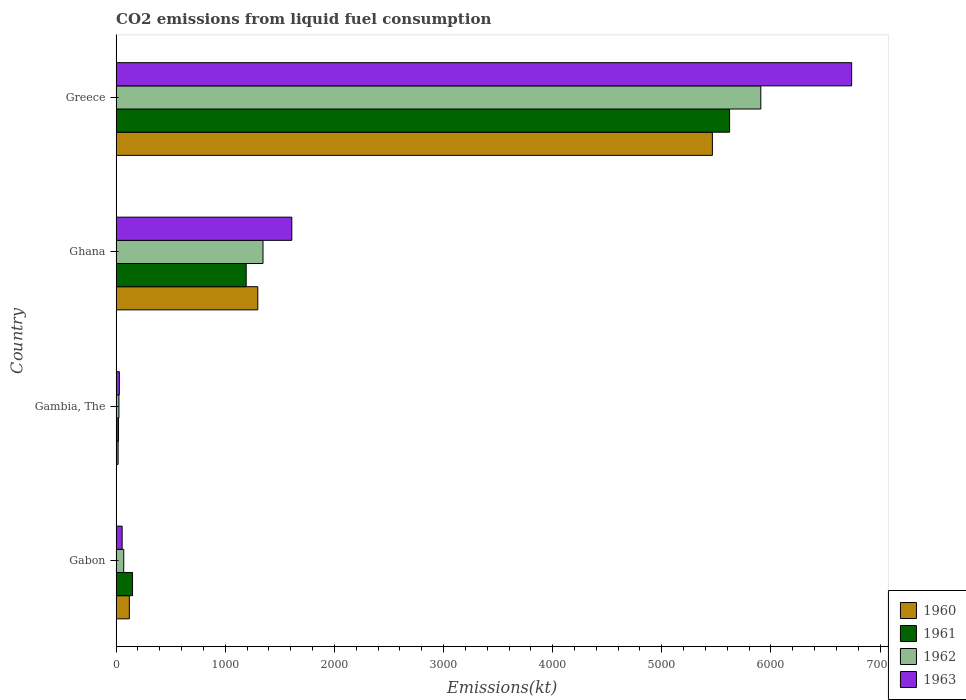How many different coloured bars are there?
Your answer should be compact. 4. How many groups of bars are there?
Keep it short and to the point. 4. Are the number of bars per tick equal to the number of legend labels?
Offer a very short reply. Yes. Are the number of bars on each tick of the Y-axis equal?
Make the answer very short. Yes. How many bars are there on the 3rd tick from the top?
Give a very brief answer. 4. What is the label of the 2nd group of bars from the top?
Provide a succinct answer. Ghana. What is the amount of CO2 emitted in 1960 in Gabon?
Your answer should be very brief. 121.01. Across all countries, what is the maximum amount of CO2 emitted in 1960?
Provide a short and direct response. 5463.83. Across all countries, what is the minimum amount of CO2 emitted in 1960?
Offer a terse response. 18.34. In which country was the amount of CO2 emitted in 1960 maximum?
Offer a terse response. Greece. In which country was the amount of CO2 emitted in 1960 minimum?
Give a very brief answer. Gambia, The. What is the total amount of CO2 emitted in 1962 in the graph?
Provide a short and direct response. 7348.67. What is the difference between the amount of CO2 emitted in 1963 in Gabon and that in Greece?
Make the answer very short. -6684.94. What is the difference between the amount of CO2 emitted in 1960 in Ghana and the amount of CO2 emitted in 1962 in Gabon?
Offer a terse response. 1228.44. What is the average amount of CO2 emitted in 1960 per country?
Keep it short and to the point. 1725.32. What is the difference between the amount of CO2 emitted in 1962 and amount of CO2 emitted in 1963 in Gabon?
Provide a short and direct response. 14.67. What is the ratio of the amount of CO2 emitted in 1961 in Gabon to that in Ghana?
Keep it short and to the point. 0.13. Is the amount of CO2 emitted in 1963 in Gabon less than that in Ghana?
Provide a short and direct response. Yes. Is the difference between the amount of CO2 emitted in 1962 in Gambia, The and Greece greater than the difference between the amount of CO2 emitted in 1963 in Gambia, The and Greece?
Ensure brevity in your answer.  Yes. What is the difference between the highest and the second highest amount of CO2 emitted in 1961?
Make the answer very short. 4429.74. What is the difference between the highest and the lowest amount of CO2 emitted in 1961?
Keep it short and to the point. 5599.51. Is it the case that in every country, the sum of the amount of CO2 emitted in 1960 and amount of CO2 emitted in 1963 is greater than the sum of amount of CO2 emitted in 1961 and amount of CO2 emitted in 1962?
Ensure brevity in your answer.  No. What does the 3rd bar from the bottom in Greece represents?
Provide a short and direct response. 1962. Is it the case that in every country, the sum of the amount of CO2 emitted in 1962 and amount of CO2 emitted in 1961 is greater than the amount of CO2 emitted in 1963?
Your response must be concise. Yes. Are all the bars in the graph horizontal?
Give a very brief answer. Yes. Where does the legend appear in the graph?
Keep it short and to the point. Bottom right. How many legend labels are there?
Provide a succinct answer. 4. What is the title of the graph?
Make the answer very short. CO2 emissions from liquid fuel consumption. What is the label or title of the X-axis?
Your response must be concise. Emissions(kt). What is the label or title of the Y-axis?
Provide a succinct answer. Country. What is the Emissions(kt) of 1960 in Gabon?
Offer a terse response. 121.01. What is the Emissions(kt) in 1961 in Gabon?
Make the answer very short. 150.35. What is the Emissions(kt) of 1962 in Gabon?
Give a very brief answer. 69.67. What is the Emissions(kt) of 1963 in Gabon?
Provide a succinct answer. 55.01. What is the Emissions(kt) in 1960 in Gambia, The?
Offer a terse response. 18.34. What is the Emissions(kt) of 1961 in Gambia, The?
Offer a very short reply. 22. What is the Emissions(kt) of 1962 in Gambia, The?
Offer a terse response. 25.67. What is the Emissions(kt) in 1963 in Gambia, The?
Your response must be concise. 29.34. What is the Emissions(kt) in 1960 in Ghana?
Provide a succinct answer. 1298.12. What is the Emissions(kt) in 1961 in Ghana?
Your answer should be compact. 1191.78. What is the Emissions(kt) of 1962 in Ghana?
Ensure brevity in your answer.  1345.79. What is the Emissions(kt) of 1963 in Ghana?
Your answer should be very brief. 1609.81. What is the Emissions(kt) of 1960 in Greece?
Your answer should be very brief. 5463.83. What is the Emissions(kt) of 1961 in Greece?
Your answer should be compact. 5621.51. What is the Emissions(kt) of 1962 in Greece?
Offer a very short reply. 5907.54. What is the Emissions(kt) of 1963 in Greece?
Your answer should be very brief. 6739.95. Across all countries, what is the maximum Emissions(kt) of 1960?
Offer a very short reply. 5463.83. Across all countries, what is the maximum Emissions(kt) in 1961?
Your answer should be compact. 5621.51. Across all countries, what is the maximum Emissions(kt) of 1962?
Offer a very short reply. 5907.54. Across all countries, what is the maximum Emissions(kt) of 1963?
Give a very brief answer. 6739.95. Across all countries, what is the minimum Emissions(kt) in 1960?
Make the answer very short. 18.34. Across all countries, what is the minimum Emissions(kt) of 1961?
Your answer should be very brief. 22. Across all countries, what is the minimum Emissions(kt) of 1962?
Your answer should be compact. 25.67. Across all countries, what is the minimum Emissions(kt) in 1963?
Provide a succinct answer. 29.34. What is the total Emissions(kt) in 1960 in the graph?
Your response must be concise. 6901.29. What is the total Emissions(kt) in 1961 in the graph?
Your response must be concise. 6985.64. What is the total Emissions(kt) of 1962 in the graph?
Your answer should be compact. 7348.67. What is the total Emissions(kt) in 1963 in the graph?
Make the answer very short. 8434.1. What is the difference between the Emissions(kt) of 1960 in Gabon and that in Gambia, The?
Ensure brevity in your answer.  102.68. What is the difference between the Emissions(kt) in 1961 in Gabon and that in Gambia, The?
Your response must be concise. 128.34. What is the difference between the Emissions(kt) of 1962 in Gabon and that in Gambia, The?
Give a very brief answer. 44. What is the difference between the Emissions(kt) of 1963 in Gabon and that in Gambia, The?
Your answer should be compact. 25.67. What is the difference between the Emissions(kt) of 1960 in Gabon and that in Ghana?
Give a very brief answer. -1177.11. What is the difference between the Emissions(kt) in 1961 in Gabon and that in Ghana?
Your response must be concise. -1041.43. What is the difference between the Emissions(kt) in 1962 in Gabon and that in Ghana?
Offer a very short reply. -1276.12. What is the difference between the Emissions(kt) in 1963 in Gabon and that in Ghana?
Offer a terse response. -1554.81. What is the difference between the Emissions(kt) in 1960 in Gabon and that in Greece?
Offer a terse response. -5342.82. What is the difference between the Emissions(kt) in 1961 in Gabon and that in Greece?
Provide a short and direct response. -5471.16. What is the difference between the Emissions(kt) in 1962 in Gabon and that in Greece?
Offer a very short reply. -5837.86. What is the difference between the Emissions(kt) of 1963 in Gabon and that in Greece?
Make the answer very short. -6684.94. What is the difference between the Emissions(kt) in 1960 in Gambia, The and that in Ghana?
Give a very brief answer. -1279.78. What is the difference between the Emissions(kt) in 1961 in Gambia, The and that in Ghana?
Provide a short and direct response. -1169.77. What is the difference between the Emissions(kt) in 1962 in Gambia, The and that in Ghana?
Offer a terse response. -1320.12. What is the difference between the Emissions(kt) of 1963 in Gambia, The and that in Ghana?
Offer a very short reply. -1580.48. What is the difference between the Emissions(kt) of 1960 in Gambia, The and that in Greece?
Your answer should be very brief. -5445.49. What is the difference between the Emissions(kt) of 1961 in Gambia, The and that in Greece?
Your answer should be compact. -5599.51. What is the difference between the Emissions(kt) of 1962 in Gambia, The and that in Greece?
Your response must be concise. -5881.87. What is the difference between the Emissions(kt) of 1963 in Gambia, The and that in Greece?
Give a very brief answer. -6710.61. What is the difference between the Emissions(kt) in 1960 in Ghana and that in Greece?
Your response must be concise. -4165.71. What is the difference between the Emissions(kt) in 1961 in Ghana and that in Greece?
Provide a short and direct response. -4429.74. What is the difference between the Emissions(kt) of 1962 in Ghana and that in Greece?
Keep it short and to the point. -4561.75. What is the difference between the Emissions(kt) of 1963 in Ghana and that in Greece?
Your response must be concise. -5130.13. What is the difference between the Emissions(kt) in 1960 in Gabon and the Emissions(kt) in 1961 in Gambia, The?
Give a very brief answer. 99.01. What is the difference between the Emissions(kt) of 1960 in Gabon and the Emissions(kt) of 1962 in Gambia, The?
Your answer should be very brief. 95.34. What is the difference between the Emissions(kt) of 1960 in Gabon and the Emissions(kt) of 1963 in Gambia, The?
Offer a terse response. 91.67. What is the difference between the Emissions(kt) in 1961 in Gabon and the Emissions(kt) in 1962 in Gambia, The?
Your answer should be very brief. 124.68. What is the difference between the Emissions(kt) in 1961 in Gabon and the Emissions(kt) in 1963 in Gambia, The?
Your response must be concise. 121.01. What is the difference between the Emissions(kt) in 1962 in Gabon and the Emissions(kt) in 1963 in Gambia, The?
Make the answer very short. 40.34. What is the difference between the Emissions(kt) of 1960 in Gabon and the Emissions(kt) of 1961 in Ghana?
Provide a short and direct response. -1070.76. What is the difference between the Emissions(kt) in 1960 in Gabon and the Emissions(kt) in 1962 in Ghana?
Give a very brief answer. -1224.78. What is the difference between the Emissions(kt) in 1960 in Gabon and the Emissions(kt) in 1963 in Ghana?
Provide a succinct answer. -1488.8. What is the difference between the Emissions(kt) of 1961 in Gabon and the Emissions(kt) of 1962 in Ghana?
Offer a terse response. -1195.44. What is the difference between the Emissions(kt) in 1961 in Gabon and the Emissions(kt) in 1963 in Ghana?
Offer a terse response. -1459.47. What is the difference between the Emissions(kt) of 1962 in Gabon and the Emissions(kt) of 1963 in Ghana?
Your answer should be very brief. -1540.14. What is the difference between the Emissions(kt) in 1960 in Gabon and the Emissions(kt) in 1961 in Greece?
Give a very brief answer. -5500.5. What is the difference between the Emissions(kt) in 1960 in Gabon and the Emissions(kt) in 1962 in Greece?
Your answer should be very brief. -5786.53. What is the difference between the Emissions(kt) in 1960 in Gabon and the Emissions(kt) in 1963 in Greece?
Provide a succinct answer. -6618.94. What is the difference between the Emissions(kt) of 1961 in Gabon and the Emissions(kt) of 1962 in Greece?
Ensure brevity in your answer.  -5757.19. What is the difference between the Emissions(kt) in 1961 in Gabon and the Emissions(kt) in 1963 in Greece?
Make the answer very short. -6589.6. What is the difference between the Emissions(kt) in 1962 in Gabon and the Emissions(kt) in 1963 in Greece?
Your answer should be compact. -6670.27. What is the difference between the Emissions(kt) in 1960 in Gambia, The and the Emissions(kt) in 1961 in Ghana?
Your answer should be compact. -1173.44. What is the difference between the Emissions(kt) of 1960 in Gambia, The and the Emissions(kt) of 1962 in Ghana?
Keep it short and to the point. -1327.45. What is the difference between the Emissions(kt) in 1960 in Gambia, The and the Emissions(kt) in 1963 in Ghana?
Provide a succinct answer. -1591.48. What is the difference between the Emissions(kt) of 1961 in Gambia, The and the Emissions(kt) of 1962 in Ghana?
Offer a terse response. -1323.79. What is the difference between the Emissions(kt) in 1961 in Gambia, The and the Emissions(kt) in 1963 in Ghana?
Give a very brief answer. -1587.81. What is the difference between the Emissions(kt) in 1962 in Gambia, The and the Emissions(kt) in 1963 in Ghana?
Provide a succinct answer. -1584.14. What is the difference between the Emissions(kt) in 1960 in Gambia, The and the Emissions(kt) in 1961 in Greece?
Give a very brief answer. -5603.18. What is the difference between the Emissions(kt) in 1960 in Gambia, The and the Emissions(kt) in 1962 in Greece?
Your response must be concise. -5889.2. What is the difference between the Emissions(kt) of 1960 in Gambia, The and the Emissions(kt) of 1963 in Greece?
Your response must be concise. -6721.61. What is the difference between the Emissions(kt) in 1961 in Gambia, The and the Emissions(kt) in 1962 in Greece?
Give a very brief answer. -5885.53. What is the difference between the Emissions(kt) in 1961 in Gambia, The and the Emissions(kt) in 1963 in Greece?
Your response must be concise. -6717.94. What is the difference between the Emissions(kt) in 1962 in Gambia, The and the Emissions(kt) in 1963 in Greece?
Your answer should be very brief. -6714.28. What is the difference between the Emissions(kt) of 1960 in Ghana and the Emissions(kt) of 1961 in Greece?
Offer a terse response. -4323.39. What is the difference between the Emissions(kt) of 1960 in Ghana and the Emissions(kt) of 1962 in Greece?
Give a very brief answer. -4609.42. What is the difference between the Emissions(kt) in 1960 in Ghana and the Emissions(kt) in 1963 in Greece?
Offer a terse response. -5441.83. What is the difference between the Emissions(kt) in 1961 in Ghana and the Emissions(kt) in 1962 in Greece?
Give a very brief answer. -4715.76. What is the difference between the Emissions(kt) of 1961 in Ghana and the Emissions(kt) of 1963 in Greece?
Provide a succinct answer. -5548.17. What is the difference between the Emissions(kt) in 1962 in Ghana and the Emissions(kt) in 1963 in Greece?
Offer a very short reply. -5394.16. What is the average Emissions(kt) of 1960 per country?
Ensure brevity in your answer.  1725.32. What is the average Emissions(kt) of 1961 per country?
Keep it short and to the point. 1746.41. What is the average Emissions(kt) of 1962 per country?
Make the answer very short. 1837.17. What is the average Emissions(kt) in 1963 per country?
Provide a succinct answer. 2108.53. What is the difference between the Emissions(kt) in 1960 and Emissions(kt) in 1961 in Gabon?
Your answer should be compact. -29.34. What is the difference between the Emissions(kt) of 1960 and Emissions(kt) of 1962 in Gabon?
Make the answer very short. 51.34. What is the difference between the Emissions(kt) of 1960 and Emissions(kt) of 1963 in Gabon?
Give a very brief answer. 66.01. What is the difference between the Emissions(kt) of 1961 and Emissions(kt) of 1962 in Gabon?
Offer a terse response. 80.67. What is the difference between the Emissions(kt) in 1961 and Emissions(kt) in 1963 in Gabon?
Offer a terse response. 95.34. What is the difference between the Emissions(kt) of 1962 and Emissions(kt) of 1963 in Gabon?
Your response must be concise. 14.67. What is the difference between the Emissions(kt) of 1960 and Emissions(kt) of 1961 in Gambia, The?
Offer a terse response. -3.67. What is the difference between the Emissions(kt) of 1960 and Emissions(kt) of 1962 in Gambia, The?
Offer a terse response. -7.33. What is the difference between the Emissions(kt) of 1960 and Emissions(kt) of 1963 in Gambia, The?
Give a very brief answer. -11. What is the difference between the Emissions(kt) of 1961 and Emissions(kt) of 1962 in Gambia, The?
Your answer should be compact. -3.67. What is the difference between the Emissions(kt) of 1961 and Emissions(kt) of 1963 in Gambia, The?
Keep it short and to the point. -7.33. What is the difference between the Emissions(kt) in 1962 and Emissions(kt) in 1963 in Gambia, The?
Ensure brevity in your answer.  -3.67. What is the difference between the Emissions(kt) in 1960 and Emissions(kt) in 1961 in Ghana?
Your answer should be very brief. 106.34. What is the difference between the Emissions(kt) of 1960 and Emissions(kt) of 1962 in Ghana?
Your answer should be compact. -47.67. What is the difference between the Emissions(kt) of 1960 and Emissions(kt) of 1963 in Ghana?
Provide a short and direct response. -311.69. What is the difference between the Emissions(kt) in 1961 and Emissions(kt) in 1962 in Ghana?
Make the answer very short. -154.01. What is the difference between the Emissions(kt) of 1961 and Emissions(kt) of 1963 in Ghana?
Offer a terse response. -418.04. What is the difference between the Emissions(kt) in 1962 and Emissions(kt) in 1963 in Ghana?
Make the answer very short. -264.02. What is the difference between the Emissions(kt) of 1960 and Emissions(kt) of 1961 in Greece?
Give a very brief answer. -157.68. What is the difference between the Emissions(kt) of 1960 and Emissions(kt) of 1962 in Greece?
Give a very brief answer. -443.71. What is the difference between the Emissions(kt) of 1960 and Emissions(kt) of 1963 in Greece?
Provide a short and direct response. -1276.12. What is the difference between the Emissions(kt) in 1961 and Emissions(kt) in 1962 in Greece?
Provide a short and direct response. -286.03. What is the difference between the Emissions(kt) in 1961 and Emissions(kt) in 1963 in Greece?
Give a very brief answer. -1118.43. What is the difference between the Emissions(kt) in 1962 and Emissions(kt) in 1963 in Greece?
Make the answer very short. -832.41. What is the ratio of the Emissions(kt) in 1961 in Gabon to that in Gambia, The?
Keep it short and to the point. 6.83. What is the ratio of the Emissions(kt) of 1962 in Gabon to that in Gambia, The?
Give a very brief answer. 2.71. What is the ratio of the Emissions(kt) of 1963 in Gabon to that in Gambia, The?
Offer a very short reply. 1.88. What is the ratio of the Emissions(kt) in 1960 in Gabon to that in Ghana?
Provide a short and direct response. 0.09. What is the ratio of the Emissions(kt) of 1961 in Gabon to that in Ghana?
Provide a succinct answer. 0.13. What is the ratio of the Emissions(kt) of 1962 in Gabon to that in Ghana?
Provide a succinct answer. 0.05. What is the ratio of the Emissions(kt) in 1963 in Gabon to that in Ghana?
Provide a short and direct response. 0.03. What is the ratio of the Emissions(kt) of 1960 in Gabon to that in Greece?
Offer a terse response. 0.02. What is the ratio of the Emissions(kt) of 1961 in Gabon to that in Greece?
Provide a succinct answer. 0.03. What is the ratio of the Emissions(kt) in 1962 in Gabon to that in Greece?
Give a very brief answer. 0.01. What is the ratio of the Emissions(kt) of 1963 in Gabon to that in Greece?
Provide a short and direct response. 0.01. What is the ratio of the Emissions(kt) in 1960 in Gambia, The to that in Ghana?
Offer a terse response. 0.01. What is the ratio of the Emissions(kt) in 1961 in Gambia, The to that in Ghana?
Make the answer very short. 0.02. What is the ratio of the Emissions(kt) in 1962 in Gambia, The to that in Ghana?
Provide a succinct answer. 0.02. What is the ratio of the Emissions(kt) of 1963 in Gambia, The to that in Ghana?
Your response must be concise. 0.02. What is the ratio of the Emissions(kt) of 1960 in Gambia, The to that in Greece?
Offer a very short reply. 0. What is the ratio of the Emissions(kt) of 1961 in Gambia, The to that in Greece?
Your response must be concise. 0. What is the ratio of the Emissions(kt) of 1962 in Gambia, The to that in Greece?
Provide a succinct answer. 0. What is the ratio of the Emissions(kt) of 1963 in Gambia, The to that in Greece?
Your response must be concise. 0. What is the ratio of the Emissions(kt) in 1960 in Ghana to that in Greece?
Your answer should be very brief. 0.24. What is the ratio of the Emissions(kt) in 1961 in Ghana to that in Greece?
Your answer should be very brief. 0.21. What is the ratio of the Emissions(kt) of 1962 in Ghana to that in Greece?
Your answer should be compact. 0.23. What is the ratio of the Emissions(kt) in 1963 in Ghana to that in Greece?
Ensure brevity in your answer.  0.24. What is the difference between the highest and the second highest Emissions(kt) in 1960?
Make the answer very short. 4165.71. What is the difference between the highest and the second highest Emissions(kt) in 1961?
Provide a succinct answer. 4429.74. What is the difference between the highest and the second highest Emissions(kt) in 1962?
Offer a very short reply. 4561.75. What is the difference between the highest and the second highest Emissions(kt) of 1963?
Make the answer very short. 5130.13. What is the difference between the highest and the lowest Emissions(kt) in 1960?
Ensure brevity in your answer.  5445.49. What is the difference between the highest and the lowest Emissions(kt) of 1961?
Provide a short and direct response. 5599.51. What is the difference between the highest and the lowest Emissions(kt) in 1962?
Your answer should be compact. 5881.87. What is the difference between the highest and the lowest Emissions(kt) in 1963?
Provide a short and direct response. 6710.61. 